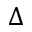<formula> <loc_0><loc_0><loc_500><loc_500>\Delta</formula> 